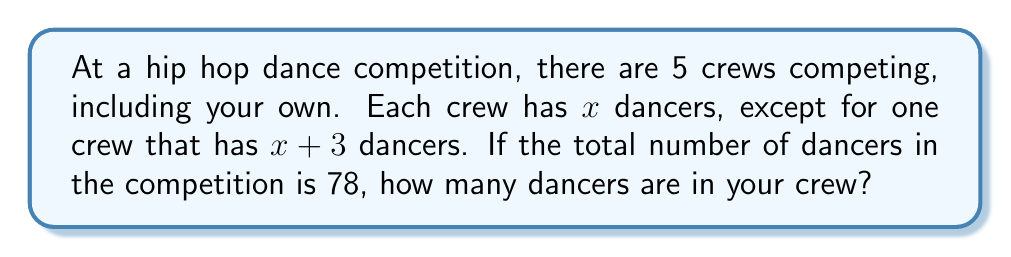What is the answer to this math problem? Let's approach this step-by-step:

1) We know there are 5 crews in total.
2) 4 crews have $x$ dancers each, and 1 crew has $x+3$ dancers.
3) The total number of dancers is 78.

We can set up an equation:

$$4x + (x+3) = 78$$

Now, let's solve this equation:

4) Simplify the left side of the equation:
   $$5x + 3 = 78$$

5) Subtract 3 from both sides:
   $$5x = 75$$

6) Divide both sides by 5:
   $$x = 15$$

Therefore, each regular crew (including yours) has 15 dancers.
Answer: 15 